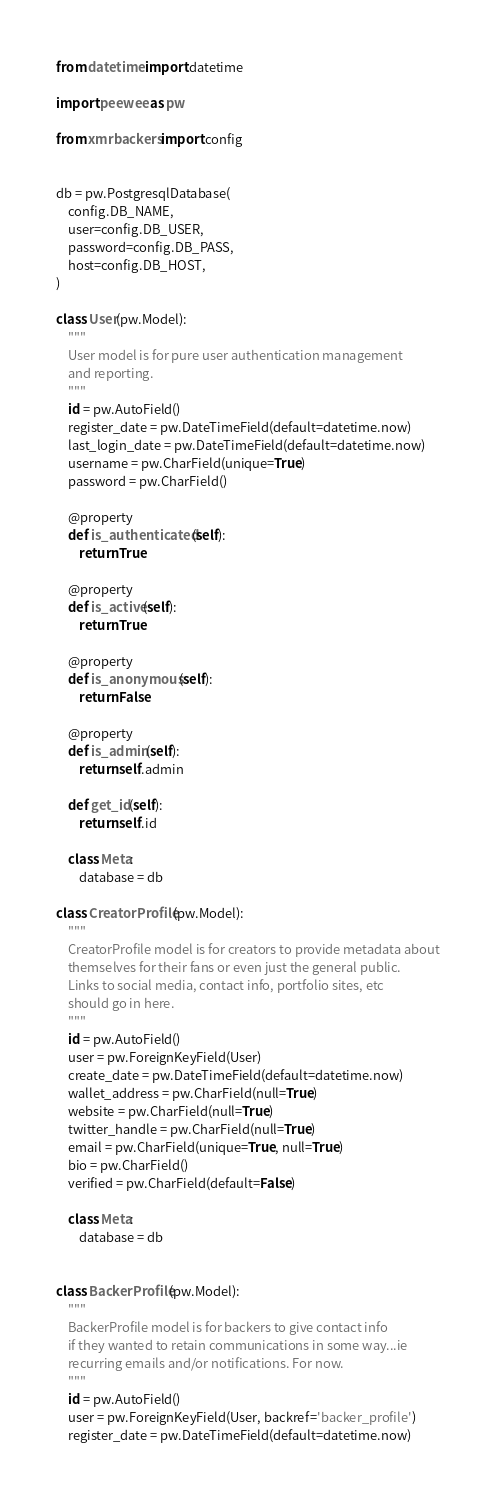<code> <loc_0><loc_0><loc_500><loc_500><_Python_>from datetime import datetime

import peewee as pw

from xmrbackers import config


db = pw.PostgresqlDatabase(
    config.DB_NAME,
    user=config.DB_USER,
    password=config.DB_PASS,
    host=config.DB_HOST,
)

class User(pw.Model):
    """
    User model is for pure user authentication management
    and reporting.
    """
    id = pw.AutoField()
    register_date = pw.DateTimeField(default=datetime.now)
    last_login_date = pw.DateTimeField(default=datetime.now)
    username = pw.CharField(unique=True)
    password = pw.CharField()

    @property
    def is_authenticated(self):
        return True

    @property
    def is_active(self):
        return True

    @property
    def is_anonymous(self):
        return False

    @property
    def is_admin(self):
        return self.admin

    def get_id(self):
        return self.id

    class Meta:
        database = db

class CreatorProfile(pw.Model):
    """
    CreatorProfile model is for creators to provide metadata about
    themselves for their fans or even just the general public.
    Links to social media, contact info, portfolio sites, etc
    should go in here.
    """
    id = pw.AutoField()
    user = pw.ForeignKeyField(User)
    create_date = pw.DateTimeField(default=datetime.now)
    wallet_address = pw.CharField(null=True)
    website = pw.CharField(null=True)
    twitter_handle = pw.CharField(null=True)
    email = pw.CharField(unique=True, null=True)
    bio = pw.CharField()
    verified = pw.CharField(default=False)

    class Meta:
        database = db


class BackerProfile(pw.Model):
    """
    BackerProfile model is for backers to give contact info
    if they wanted to retain communications in some way...ie
    recurring emails and/or notifications. For now.
    """
    id = pw.AutoField()
    user = pw.ForeignKeyField(User, backref='backer_profile')
    register_date = pw.DateTimeField(default=datetime.now)</code> 